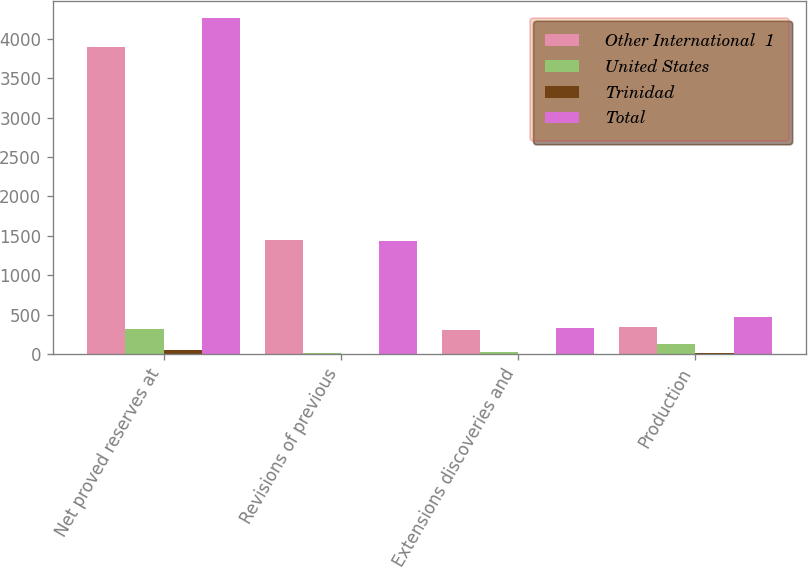Convert chart. <chart><loc_0><loc_0><loc_500><loc_500><stacked_bar_chart><ecel><fcel>Net proved reserves at<fcel>Revisions of previous<fcel>Extensions discoveries and<fcel>Production<nl><fcel>Other International  1<fcel>3898.5<fcel>1453.1<fcel>306.3<fcel>337.3<nl><fcel>United States<fcel>313.4<fcel>16.8<fcel>21.7<fcel>127.5<nl><fcel>Trinidad<fcel>51.2<fcel>5.6<fcel>4.4<fcel>10.9<nl><fcel>Total<fcel>4263.1<fcel>1430.7<fcel>332.4<fcel>475.7<nl></chart> 